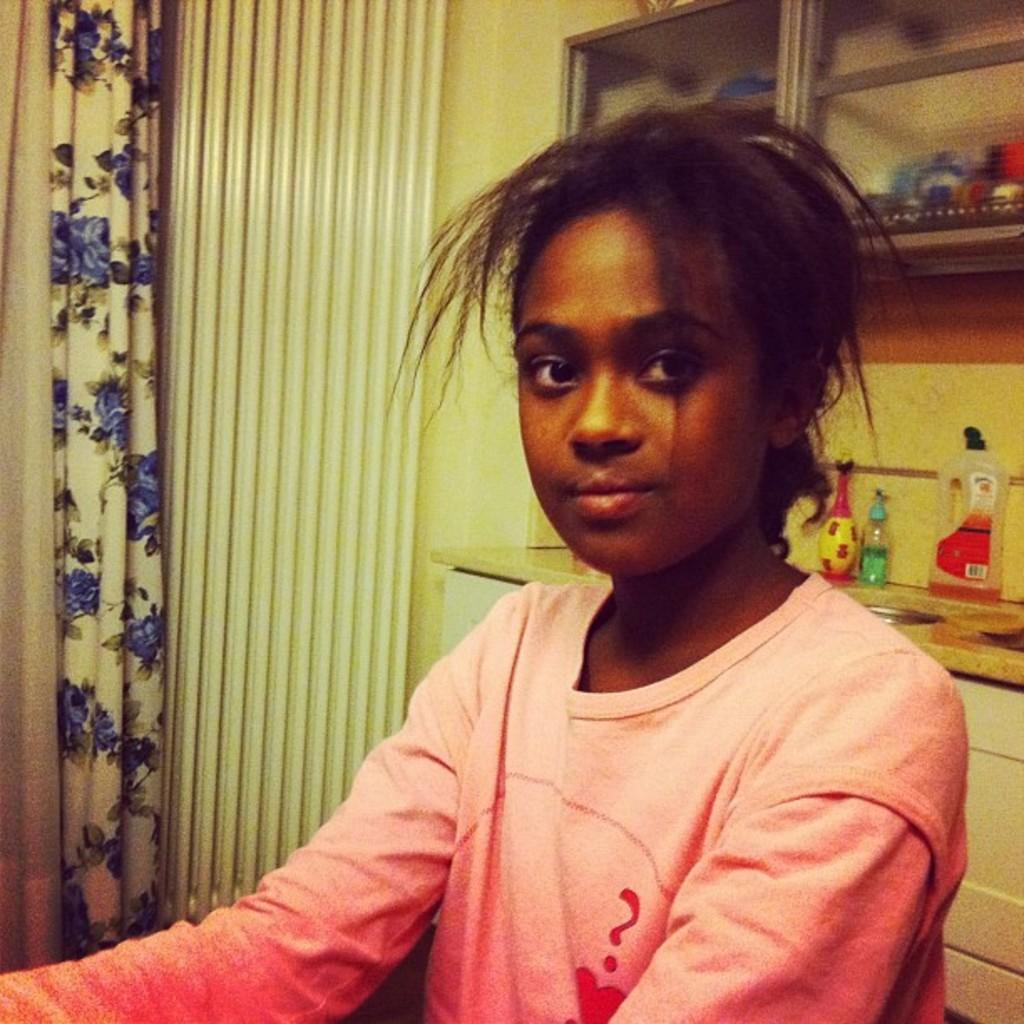Can you describe this image briefly? In this image we can see a girl. In the background we can see wall, curtain, bottles on the sink table, objects in the cupboard and it has glass doors. 